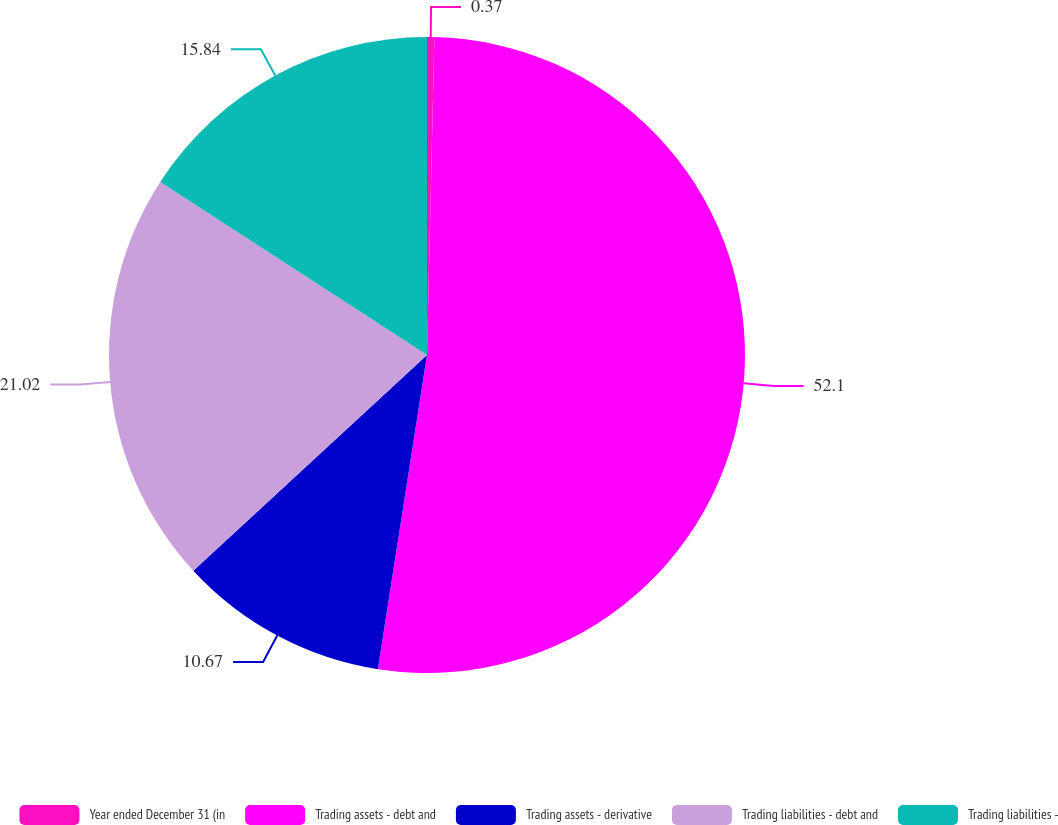Convert chart to OTSL. <chart><loc_0><loc_0><loc_500><loc_500><pie_chart><fcel>Year ended December 31 (in<fcel>Trading assets - debt and<fcel>Trading assets - derivative<fcel>Trading liabilities - debt and<fcel>Trading liabilities -<nl><fcel>0.37%<fcel>52.1%<fcel>10.67%<fcel>21.02%<fcel>15.84%<nl></chart> 